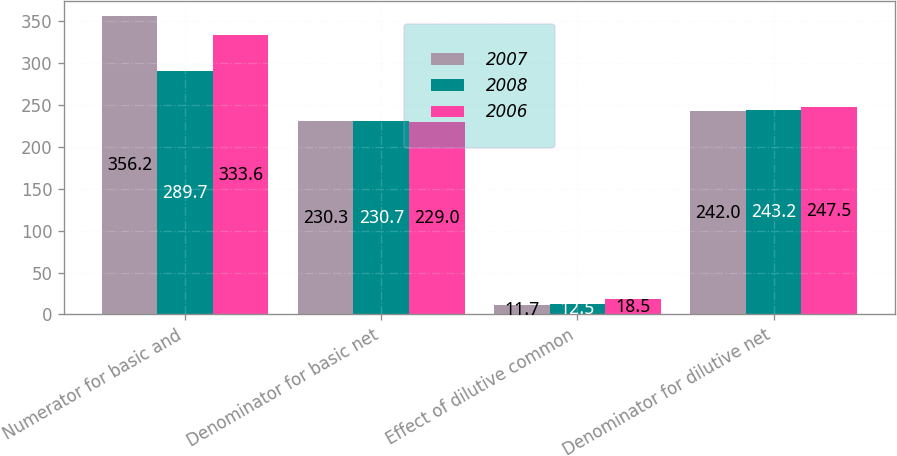Convert chart to OTSL. <chart><loc_0><loc_0><loc_500><loc_500><stacked_bar_chart><ecel><fcel>Numerator for basic and<fcel>Denominator for basic net<fcel>Effect of dilutive common<fcel>Denominator for dilutive net<nl><fcel>2007<fcel>356.2<fcel>230.3<fcel>11.7<fcel>242<nl><fcel>2008<fcel>289.7<fcel>230.7<fcel>12.5<fcel>243.2<nl><fcel>2006<fcel>333.6<fcel>229<fcel>18.5<fcel>247.5<nl></chart> 